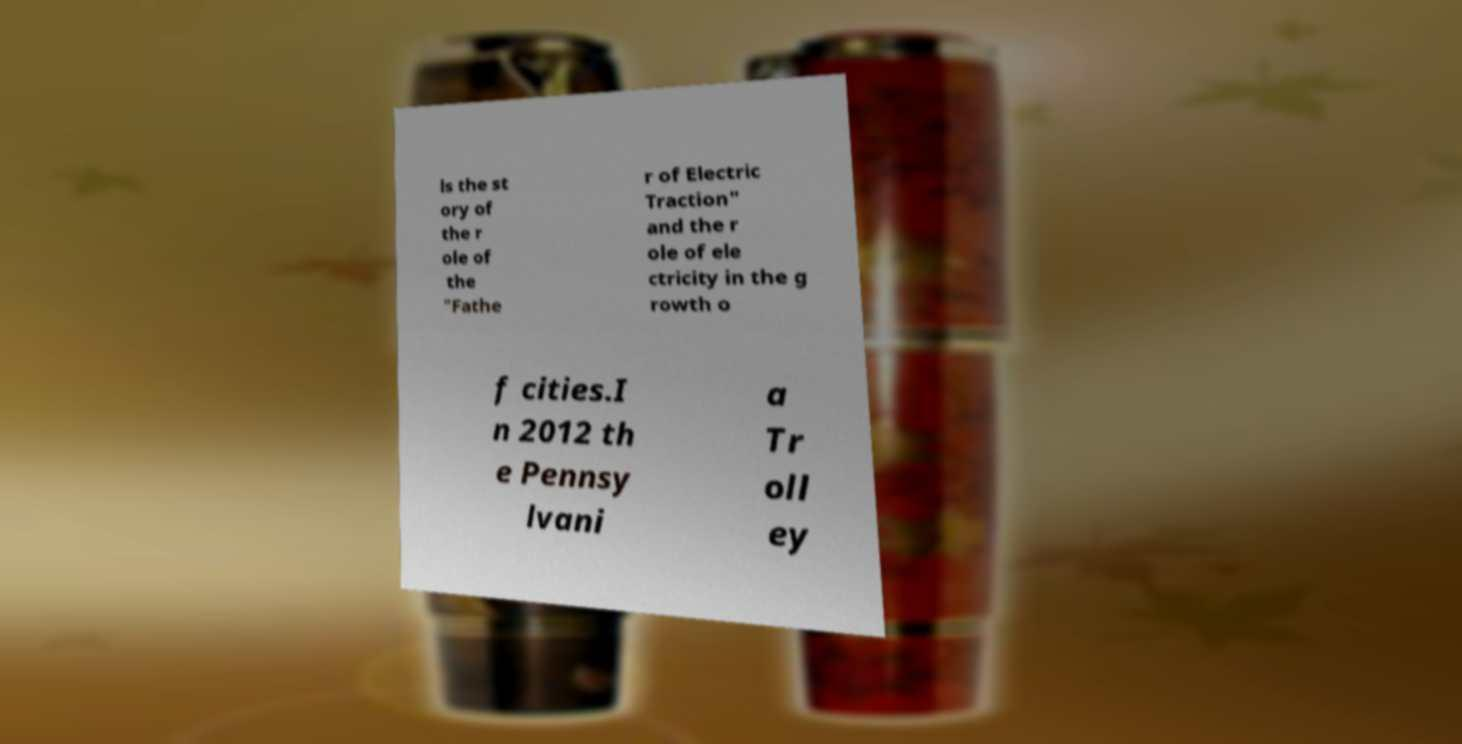Please read and relay the text visible in this image. What does it say? ls the st ory of the r ole of the "Fathe r of Electric Traction" and the r ole of ele ctricity in the g rowth o f cities.I n 2012 th e Pennsy lvani a Tr oll ey 